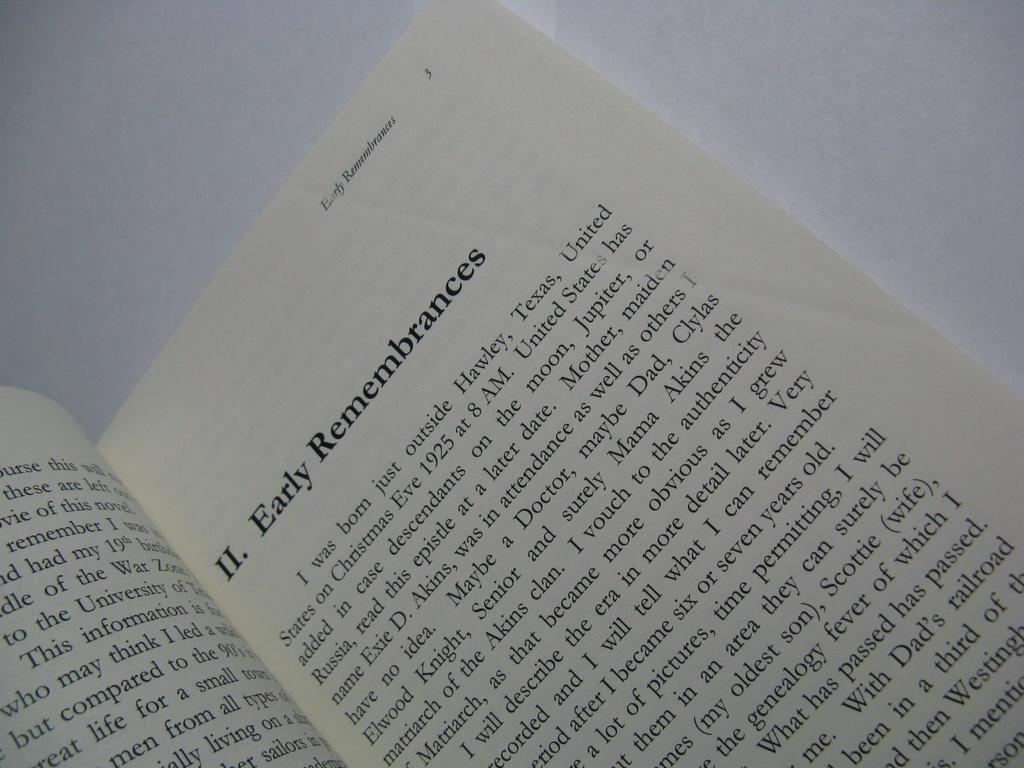Which country name can be seen in the text?
Provide a succinct answer. United states. What is the title of the page on the right?
Make the answer very short. Early remembrances. 